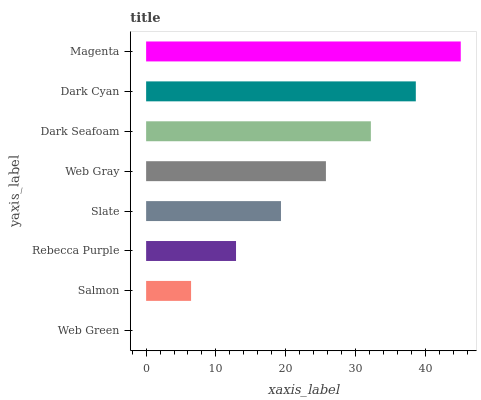Is Web Green the minimum?
Answer yes or no. Yes. Is Magenta the maximum?
Answer yes or no. Yes. Is Salmon the minimum?
Answer yes or no. No. Is Salmon the maximum?
Answer yes or no. No. Is Salmon greater than Web Green?
Answer yes or no. Yes. Is Web Green less than Salmon?
Answer yes or no. Yes. Is Web Green greater than Salmon?
Answer yes or no. No. Is Salmon less than Web Green?
Answer yes or no. No. Is Web Gray the high median?
Answer yes or no. Yes. Is Slate the low median?
Answer yes or no. Yes. Is Dark Seafoam the high median?
Answer yes or no. No. Is Dark Seafoam the low median?
Answer yes or no. No. 